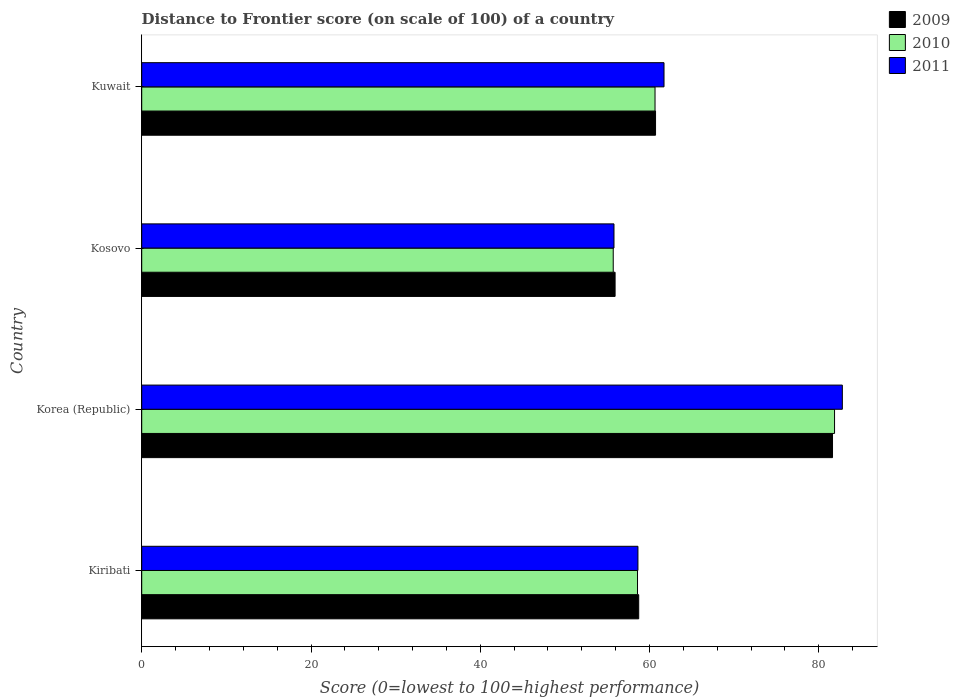How many groups of bars are there?
Provide a succinct answer. 4. Are the number of bars per tick equal to the number of legend labels?
Offer a terse response. Yes. Are the number of bars on each tick of the Y-axis equal?
Keep it short and to the point. Yes. How many bars are there on the 2nd tick from the top?
Your answer should be compact. 3. What is the label of the 1st group of bars from the top?
Your answer should be compact. Kuwait. What is the distance to frontier score of in 2009 in Kosovo?
Your answer should be very brief. 55.93. Across all countries, what is the maximum distance to frontier score of in 2009?
Your answer should be compact. 81.62. Across all countries, what is the minimum distance to frontier score of in 2010?
Give a very brief answer. 55.71. In which country was the distance to frontier score of in 2009 minimum?
Keep it short and to the point. Kosovo. What is the total distance to frontier score of in 2009 in the graph?
Offer a very short reply. 256.98. What is the difference between the distance to frontier score of in 2011 in Korea (Republic) and that in Kuwait?
Offer a very short reply. 21.07. What is the difference between the distance to frontier score of in 2010 in Kiribati and the distance to frontier score of in 2011 in Korea (Republic)?
Ensure brevity in your answer.  -24.2. What is the average distance to frontier score of in 2011 per country?
Offer a very short reply. 64.73. What is the difference between the distance to frontier score of in 2010 and distance to frontier score of in 2011 in Kiribati?
Make the answer very short. -0.05. In how many countries, is the distance to frontier score of in 2010 greater than 80 ?
Make the answer very short. 1. What is the ratio of the distance to frontier score of in 2009 in Korea (Republic) to that in Kuwait?
Provide a succinct answer. 1.34. What is the difference between the highest and the second highest distance to frontier score of in 2010?
Your response must be concise. 21.21. What is the difference between the highest and the lowest distance to frontier score of in 2010?
Your answer should be compact. 26.15. In how many countries, is the distance to frontier score of in 2011 greater than the average distance to frontier score of in 2011 taken over all countries?
Ensure brevity in your answer.  1. How many bars are there?
Offer a very short reply. 12. Are all the bars in the graph horizontal?
Ensure brevity in your answer.  Yes. What is the difference between two consecutive major ticks on the X-axis?
Provide a succinct answer. 20. Does the graph contain grids?
Provide a succinct answer. No. Where does the legend appear in the graph?
Ensure brevity in your answer.  Top right. How are the legend labels stacked?
Your answer should be very brief. Vertical. What is the title of the graph?
Provide a succinct answer. Distance to Frontier score (on scale of 100) of a country. What is the label or title of the X-axis?
Provide a short and direct response. Score (0=lowest to 100=highest performance). What is the label or title of the Y-axis?
Your answer should be very brief. Country. What is the Score (0=lowest to 100=highest performance) in 2009 in Kiribati?
Your answer should be compact. 58.72. What is the Score (0=lowest to 100=highest performance) of 2010 in Kiribati?
Provide a succinct answer. 58.58. What is the Score (0=lowest to 100=highest performance) in 2011 in Kiribati?
Your answer should be very brief. 58.63. What is the Score (0=lowest to 100=highest performance) of 2009 in Korea (Republic)?
Give a very brief answer. 81.62. What is the Score (0=lowest to 100=highest performance) of 2010 in Korea (Republic)?
Offer a very short reply. 81.86. What is the Score (0=lowest to 100=highest performance) in 2011 in Korea (Republic)?
Give a very brief answer. 82.78. What is the Score (0=lowest to 100=highest performance) in 2009 in Kosovo?
Make the answer very short. 55.93. What is the Score (0=lowest to 100=highest performance) of 2010 in Kosovo?
Your response must be concise. 55.71. What is the Score (0=lowest to 100=highest performance) in 2011 in Kosovo?
Give a very brief answer. 55.8. What is the Score (0=lowest to 100=highest performance) in 2009 in Kuwait?
Provide a short and direct response. 60.71. What is the Score (0=lowest to 100=highest performance) of 2010 in Kuwait?
Provide a succinct answer. 60.65. What is the Score (0=lowest to 100=highest performance) in 2011 in Kuwait?
Provide a succinct answer. 61.71. Across all countries, what is the maximum Score (0=lowest to 100=highest performance) of 2009?
Your answer should be very brief. 81.62. Across all countries, what is the maximum Score (0=lowest to 100=highest performance) of 2010?
Offer a terse response. 81.86. Across all countries, what is the maximum Score (0=lowest to 100=highest performance) of 2011?
Your answer should be very brief. 82.78. Across all countries, what is the minimum Score (0=lowest to 100=highest performance) in 2009?
Offer a very short reply. 55.93. Across all countries, what is the minimum Score (0=lowest to 100=highest performance) of 2010?
Provide a short and direct response. 55.71. Across all countries, what is the minimum Score (0=lowest to 100=highest performance) in 2011?
Make the answer very short. 55.8. What is the total Score (0=lowest to 100=highest performance) of 2009 in the graph?
Keep it short and to the point. 256.98. What is the total Score (0=lowest to 100=highest performance) in 2010 in the graph?
Your answer should be very brief. 256.8. What is the total Score (0=lowest to 100=highest performance) of 2011 in the graph?
Provide a succinct answer. 258.92. What is the difference between the Score (0=lowest to 100=highest performance) of 2009 in Kiribati and that in Korea (Republic)?
Keep it short and to the point. -22.9. What is the difference between the Score (0=lowest to 100=highest performance) in 2010 in Kiribati and that in Korea (Republic)?
Provide a short and direct response. -23.28. What is the difference between the Score (0=lowest to 100=highest performance) of 2011 in Kiribati and that in Korea (Republic)?
Provide a short and direct response. -24.15. What is the difference between the Score (0=lowest to 100=highest performance) of 2009 in Kiribati and that in Kosovo?
Ensure brevity in your answer.  2.79. What is the difference between the Score (0=lowest to 100=highest performance) in 2010 in Kiribati and that in Kosovo?
Ensure brevity in your answer.  2.87. What is the difference between the Score (0=lowest to 100=highest performance) of 2011 in Kiribati and that in Kosovo?
Provide a short and direct response. 2.83. What is the difference between the Score (0=lowest to 100=highest performance) in 2009 in Kiribati and that in Kuwait?
Your answer should be compact. -1.99. What is the difference between the Score (0=lowest to 100=highest performance) in 2010 in Kiribati and that in Kuwait?
Offer a very short reply. -2.07. What is the difference between the Score (0=lowest to 100=highest performance) in 2011 in Kiribati and that in Kuwait?
Your answer should be compact. -3.08. What is the difference between the Score (0=lowest to 100=highest performance) in 2009 in Korea (Republic) and that in Kosovo?
Provide a short and direct response. 25.69. What is the difference between the Score (0=lowest to 100=highest performance) in 2010 in Korea (Republic) and that in Kosovo?
Your answer should be compact. 26.15. What is the difference between the Score (0=lowest to 100=highest performance) of 2011 in Korea (Republic) and that in Kosovo?
Your answer should be compact. 26.98. What is the difference between the Score (0=lowest to 100=highest performance) of 2009 in Korea (Republic) and that in Kuwait?
Provide a succinct answer. 20.91. What is the difference between the Score (0=lowest to 100=highest performance) in 2010 in Korea (Republic) and that in Kuwait?
Your answer should be compact. 21.21. What is the difference between the Score (0=lowest to 100=highest performance) in 2011 in Korea (Republic) and that in Kuwait?
Give a very brief answer. 21.07. What is the difference between the Score (0=lowest to 100=highest performance) of 2009 in Kosovo and that in Kuwait?
Provide a succinct answer. -4.78. What is the difference between the Score (0=lowest to 100=highest performance) in 2010 in Kosovo and that in Kuwait?
Ensure brevity in your answer.  -4.94. What is the difference between the Score (0=lowest to 100=highest performance) in 2011 in Kosovo and that in Kuwait?
Your answer should be compact. -5.91. What is the difference between the Score (0=lowest to 100=highest performance) in 2009 in Kiribati and the Score (0=lowest to 100=highest performance) in 2010 in Korea (Republic)?
Your answer should be very brief. -23.14. What is the difference between the Score (0=lowest to 100=highest performance) of 2009 in Kiribati and the Score (0=lowest to 100=highest performance) of 2011 in Korea (Republic)?
Your answer should be compact. -24.06. What is the difference between the Score (0=lowest to 100=highest performance) in 2010 in Kiribati and the Score (0=lowest to 100=highest performance) in 2011 in Korea (Republic)?
Offer a terse response. -24.2. What is the difference between the Score (0=lowest to 100=highest performance) of 2009 in Kiribati and the Score (0=lowest to 100=highest performance) of 2010 in Kosovo?
Your response must be concise. 3.01. What is the difference between the Score (0=lowest to 100=highest performance) in 2009 in Kiribati and the Score (0=lowest to 100=highest performance) in 2011 in Kosovo?
Your response must be concise. 2.92. What is the difference between the Score (0=lowest to 100=highest performance) of 2010 in Kiribati and the Score (0=lowest to 100=highest performance) of 2011 in Kosovo?
Offer a very short reply. 2.78. What is the difference between the Score (0=lowest to 100=highest performance) of 2009 in Kiribati and the Score (0=lowest to 100=highest performance) of 2010 in Kuwait?
Your response must be concise. -1.93. What is the difference between the Score (0=lowest to 100=highest performance) in 2009 in Kiribati and the Score (0=lowest to 100=highest performance) in 2011 in Kuwait?
Make the answer very short. -2.99. What is the difference between the Score (0=lowest to 100=highest performance) of 2010 in Kiribati and the Score (0=lowest to 100=highest performance) of 2011 in Kuwait?
Your answer should be very brief. -3.13. What is the difference between the Score (0=lowest to 100=highest performance) in 2009 in Korea (Republic) and the Score (0=lowest to 100=highest performance) in 2010 in Kosovo?
Offer a terse response. 25.91. What is the difference between the Score (0=lowest to 100=highest performance) of 2009 in Korea (Republic) and the Score (0=lowest to 100=highest performance) of 2011 in Kosovo?
Your response must be concise. 25.82. What is the difference between the Score (0=lowest to 100=highest performance) in 2010 in Korea (Republic) and the Score (0=lowest to 100=highest performance) in 2011 in Kosovo?
Ensure brevity in your answer.  26.06. What is the difference between the Score (0=lowest to 100=highest performance) in 2009 in Korea (Republic) and the Score (0=lowest to 100=highest performance) in 2010 in Kuwait?
Provide a succinct answer. 20.97. What is the difference between the Score (0=lowest to 100=highest performance) in 2009 in Korea (Republic) and the Score (0=lowest to 100=highest performance) in 2011 in Kuwait?
Keep it short and to the point. 19.91. What is the difference between the Score (0=lowest to 100=highest performance) of 2010 in Korea (Republic) and the Score (0=lowest to 100=highest performance) of 2011 in Kuwait?
Make the answer very short. 20.15. What is the difference between the Score (0=lowest to 100=highest performance) in 2009 in Kosovo and the Score (0=lowest to 100=highest performance) in 2010 in Kuwait?
Make the answer very short. -4.72. What is the difference between the Score (0=lowest to 100=highest performance) in 2009 in Kosovo and the Score (0=lowest to 100=highest performance) in 2011 in Kuwait?
Your answer should be very brief. -5.78. What is the average Score (0=lowest to 100=highest performance) of 2009 per country?
Provide a succinct answer. 64.25. What is the average Score (0=lowest to 100=highest performance) of 2010 per country?
Offer a terse response. 64.2. What is the average Score (0=lowest to 100=highest performance) of 2011 per country?
Offer a very short reply. 64.73. What is the difference between the Score (0=lowest to 100=highest performance) of 2009 and Score (0=lowest to 100=highest performance) of 2010 in Kiribati?
Your answer should be very brief. 0.14. What is the difference between the Score (0=lowest to 100=highest performance) in 2009 and Score (0=lowest to 100=highest performance) in 2011 in Kiribati?
Give a very brief answer. 0.09. What is the difference between the Score (0=lowest to 100=highest performance) of 2009 and Score (0=lowest to 100=highest performance) of 2010 in Korea (Republic)?
Your response must be concise. -0.24. What is the difference between the Score (0=lowest to 100=highest performance) of 2009 and Score (0=lowest to 100=highest performance) of 2011 in Korea (Republic)?
Ensure brevity in your answer.  -1.16. What is the difference between the Score (0=lowest to 100=highest performance) in 2010 and Score (0=lowest to 100=highest performance) in 2011 in Korea (Republic)?
Offer a terse response. -0.92. What is the difference between the Score (0=lowest to 100=highest performance) in 2009 and Score (0=lowest to 100=highest performance) in 2010 in Kosovo?
Your response must be concise. 0.22. What is the difference between the Score (0=lowest to 100=highest performance) in 2009 and Score (0=lowest to 100=highest performance) in 2011 in Kosovo?
Make the answer very short. 0.13. What is the difference between the Score (0=lowest to 100=highest performance) in 2010 and Score (0=lowest to 100=highest performance) in 2011 in Kosovo?
Your answer should be very brief. -0.09. What is the difference between the Score (0=lowest to 100=highest performance) of 2009 and Score (0=lowest to 100=highest performance) of 2011 in Kuwait?
Keep it short and to the point. -1. What is the difference between the Score (0=lowest to 100=highest performance) of 2010 and Score (0=lowest to 100=highest performance) of 2011 in Kuwait?
Provide a short and direct response. -1.06. What is the ratio of the Score (0=lowest to 100=highest performance) of 2009 in Kiribati to that in Korea (Republic)?
Ensure brevity in your answer.  0.72. What is the ratio of the Score (0=lowest to 100=highest performance) in 2010 in Kiribati to that in Korea (Republic)?
Keep it short and to the point. 0.72. What is the ratio of the Score (0=lowest to 100=highest performance) in 2011 in Kiribati to that in Korea (Republic)?
Your response must be concise. 0.71. What is the ratio of the Score (0=lowest to 100=highest performance) in 2009 in Kiribati to that in Kosovo?
Provide a succinct answer. 1.05. What is the ratio of the Score (0=lowest to 100=highest performance) of 2010 in Kiribati to that in Kosovo?
Provide a succinct answer. 1.05. What is the ratio of the Score (0=lowest to 100=highest performance) in 2011 in Kiribati to that in Kosovo?
Give a very brief answer. 1.05. What is the ratio of the Score (0=lowest to 100=highest performance) of 2009 in Kiribati to that in Kuwait?
Give a very brief answer. 0.97. What is the ratio of the Score (0=lowest to 100=highest performance) in 2010 in Kiribati to that in Kuwait?
Make the answer very short. 0.97. What is the ratio of the Score (0=lowest to 100=highest performance) in 2011 in Kiribati to that in Kuwait?
Your answer should be compact. 0.95. What is the ratio of the Score (0=lowest to 100=highest performance) in 2009 in Korea (Republic) to that in Kosovo?
Ensure brevity in your answer.  1.46. What is the ratio of the Score (0=lowest to 100=highest performance) of 2010 in Korea (Republic) to that in Kosovo?
Keep it short and to the point. 1.47. What is the ratio of the Score (0=lowest to 100=highest performance) in 2011 in Korea (Republic) to that in Kosovo?
Your response must be concise. 1.48. What is the ratio of the Score (0=lowest to 100=highest performance) in 2009 in Korea (Republic) to that in Kuwait?
Offer a terse response. 1.34. What is the ratio of the Score (0=lowest to 100=highest performance) of 2010 in Korea (Republic) to that in Kuwait?
Keep it short and to the point. 1.35. What is the ratio of the Score (0=lowest to 100=highest performance) in 2011 in Korea (Republic) to that in Kuwait?
Offer a very short reply. 1.34. What is the ratio of the Score (0=lowest to 100=highest performance) of 2009 in Kosovo to that in Kuwait?
Give a very brief answer. 0.92. What is the ratio of the Score (0=lowest to 100=highest performance) in 2010 in Kosovo to that in Kuwait?
Offer a very short reply. 0.92. What is the ratio of the Score (0=lowest to 100=highest performance) of 2011 in Kosovo to that in Kuwait?
Your answer should be very brief. 0.9. What is the difference between the highest and the second highest Score (0=lowest to 100=highest performance) of 2009?
Offer a terse response. 20.91. What is the difference between the highest and the second highest Score (0=lowest to 100=highest performance) in 2010?
Give a very brief answer. 21.21. What is the difference between the highest and the second highest Score (0=lowest to 100=highest performance) of 2011?
Make the answer very short. 21.07. What is the difference between the highest and the lowest Score (0=lowest to 100=highest performance) in 2009?
Your answer should be compact. 25.69. What is the difference between the highest and the lowest Score (0=lowest to 100=highest performance) in 2010?
Offer a very short reply. 26.15. What is the difference between the highest and the lowest Score (0=lowest to 100=highest performance) in 2011?
Provide a short and direct response. 26.98. 